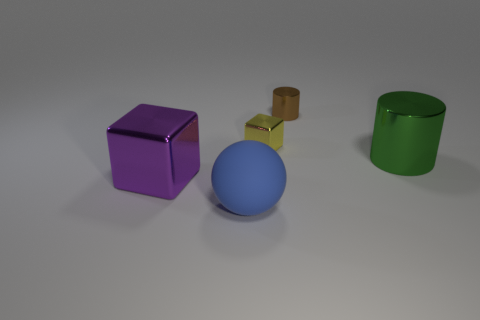Are there any shiny spheres that have the same size as the purple metal block?
Your response must be concise. No. There is another metallic thing that is the same shape as the small yellow thing; what color is it?
Provide a succinct answer. Purple. Is the size of the metallic cube on the right side of the purple thing the same as the shiny cube to the left of the big blue ball?
Your answer should be very brief. No. Is there a purple metallic thing that has the same shape as the green shiny thing?
Offer a very short reply. No. Are there an equal number of tiny brown shiny objects left of the blue rubber sphere and tiny cyan blocks?
Keep it short and to the point. Yes. Does the purple metal thing have the same size as the metallic cylinder that is right of the tiny cylinder?
Provide a short and direct response. Yes. How many brown cylinders are made of the same material as the yellow block?
Offer a very short reply. 1. Do the purple block and the green cylinder have the same size?
Keep it short and to the point. Yes. Is there any other thing that is the same color as the large matte object?
Your answer should be very brief. No. What is the shape of the metal object that is both right of the sphere and in front of the yellow cube?
Provide a short and direct response. Cylinder. 